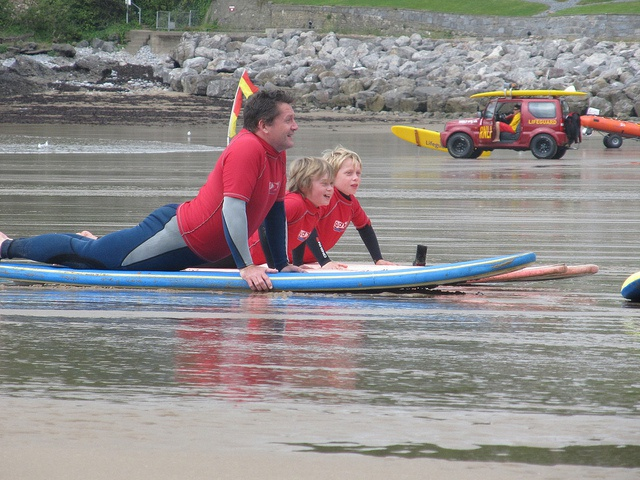Describe the objects in this image and their specific colors. I can see people in darkgreen, black, navy, darkgray, and brown tones, surfboard in darkgreen, lightblue, blue, and gray tones, truck in darkgreen, gray, black, brown, and darkgray tones, people in darkgreen, brown, darkgray, and black tones, and people in darkgreen, brown, lightpink, and darkgray tones in this image. 